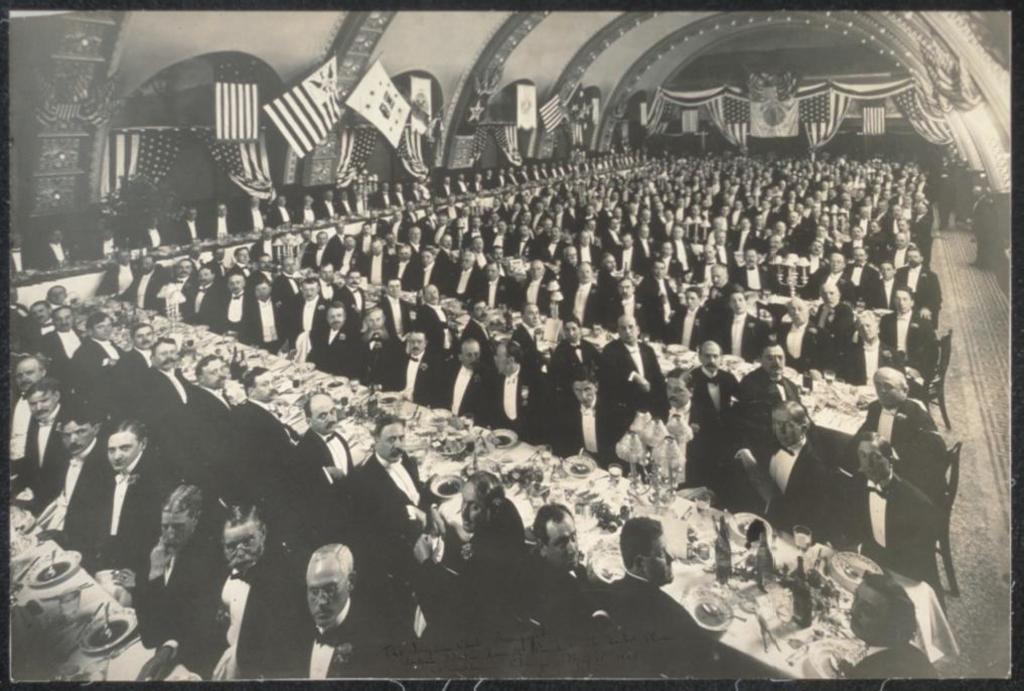Please provide a concise description of this image. In this image I can see number of people, tables, chairs and on these tables I can see number of plates, bottles, spoons and few other things. I can see all of them are wearing blazers, shirt and bow ties. In the background I can see number of flags and I can see this image is black and white in colour. 